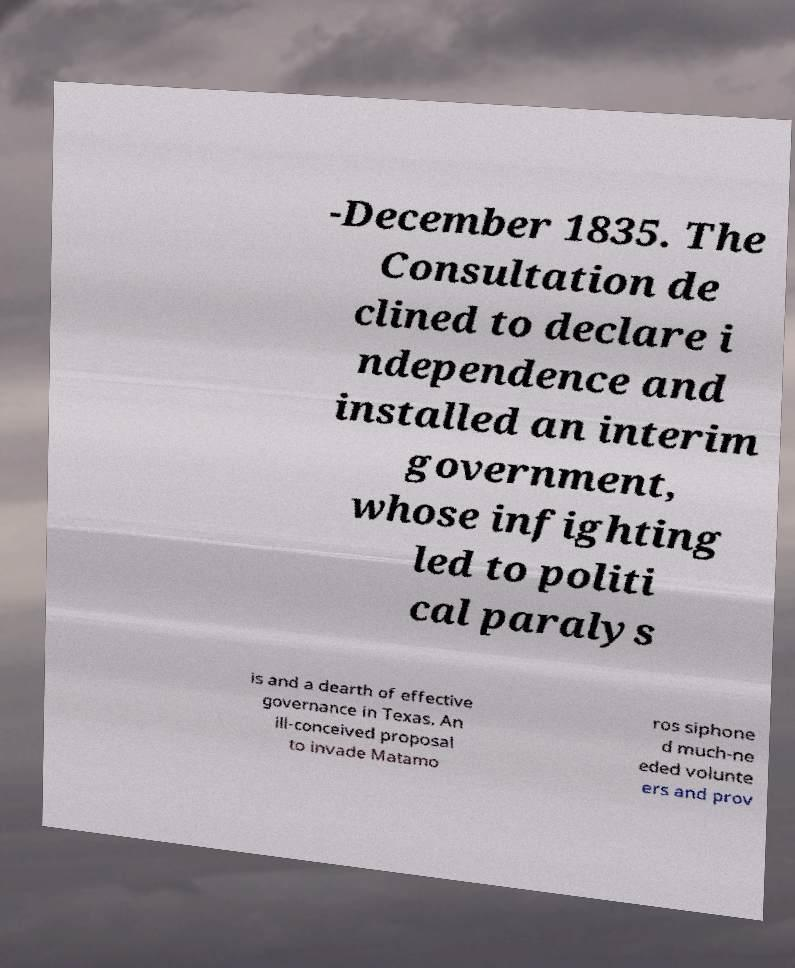What messages or text are displayed in this image? I need them in a readable, typed format. -December 1835. The Consultation de clined to declare i ndependence and installed an interim government, whose infighting led to politi cal paralys is and a dearth of effective governance in Texas. An ill-conceived proposal to invade Matamo ros siphone d much-ne eded volunte ers and prov 